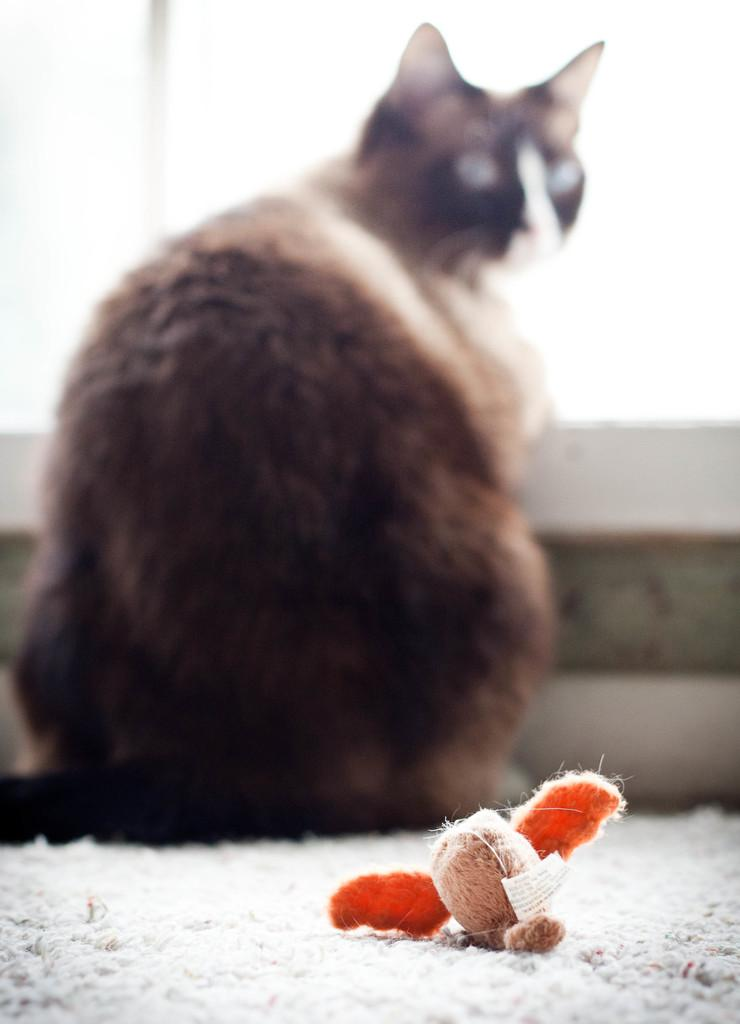What type of animal is present in the image? There is a cat in the image. What is the length of the cord attached to the cat in the image? There is no cord attached to the cat in the image. 